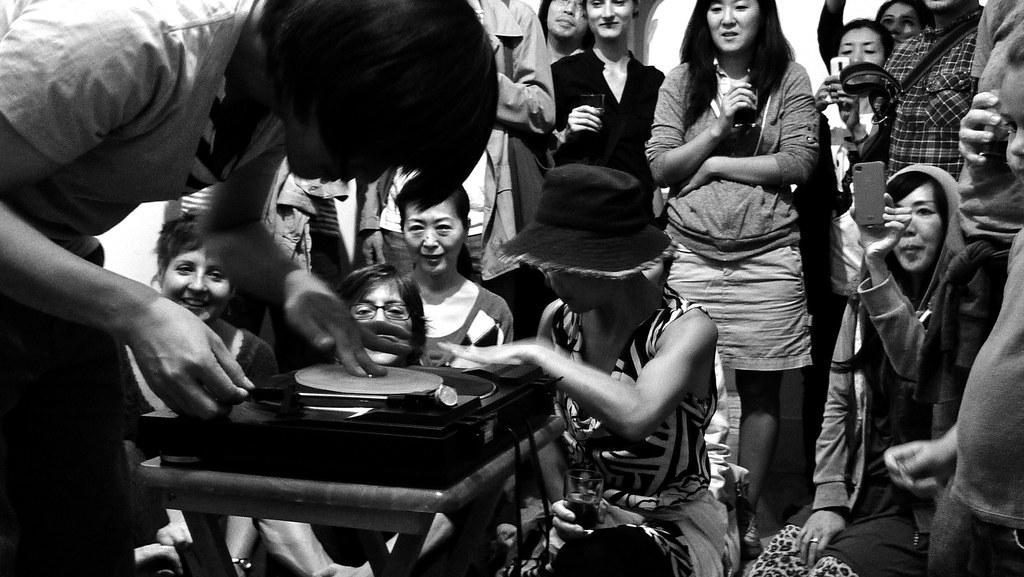Could you give a brief overview of what you see in this image? In this image I can see the group of people with different color dresses. I can see one person is wearing the hat and few people are holding the mobiles. I can see an object in-front of few people. And this is a black and white image. 